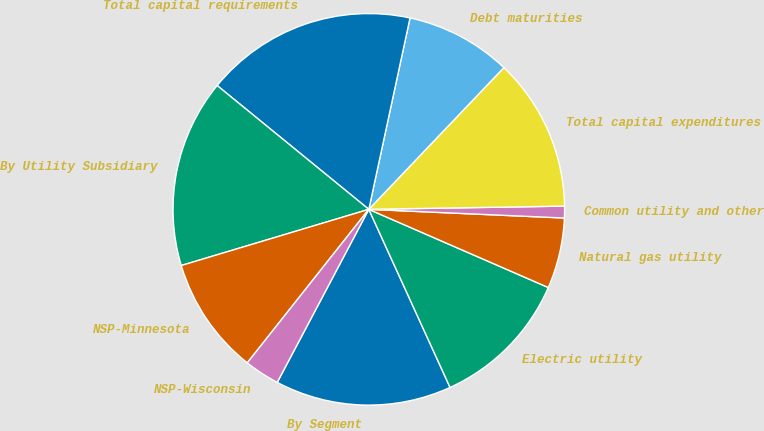Convert chart. <chart><loc_0><loc_0><loc_500><loc_500><pie_chart><fcel>By Segment<fcel>Electric utility<fcel>Natural gas utility<fcel>Common utility and other<fcel>Total capital expenditures<fcel>Debt maturities<fcel>Total capital requirements<fcel>By Utility Subsidiary<fcel>NSP-Minnesota<fcel>NSP-Wisconsin<nl><fcel>14.56%<fcel>11.65%<fcel>5.83%<fcel>0.97%<fcel>12.62%<fcel>8.74%<fcel>17.48%<fcel>15.53%<fcel>9.71%<fcel>2.91%<nl></chart> 